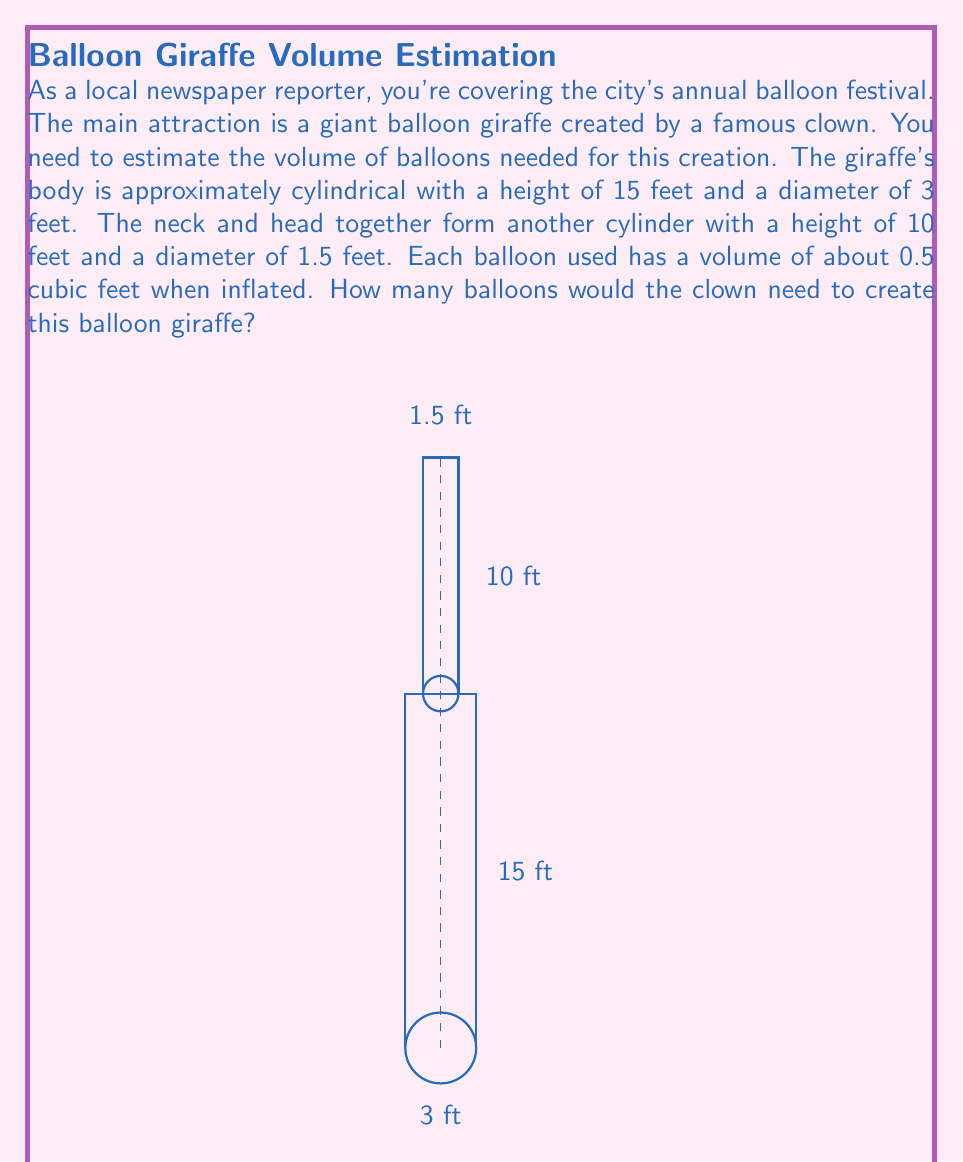Show me your answer to this math problem. Let's break this down step-by-step:

1) First, we need to calculate the volume of the giraffe's body:
   Volume of a cylinder = $\pi r^2 h$
   $r = 1.5$ feet (half the diameter)
   $h = 15$ feet
   $V_{body} = \pi (1.5)^2 (15) = 33.75\pi$ cubic feet

2) Next, calculate the volume of the neck and head:
   $r = 0.75$ feet (half the diameter)
   $h = 10$ feet
   $V_{neck} = \pi (0.75)^2 (10) = 5.625\pi$ cubic feet

3) Total volume of the balloon giraffe:
   $V_{total} = V_{body} + V_{neck} = 33.75\pi + 5.625\pi = 39.375\pi$ cubic feet

4) Convert $\pi$ to a decimal (rounded to 3 decimal places):
   $V_{total} = 39.375 * 3.142 = 123.716$ cubic feet

5) Each balloon has a volume of 0.5 cubic feet, so we divide the total volume by 0.5:
   Number of balloons = $\frac{123.716}{0.5} = 247.432$

6) Since we can't use a fraction of a balloon, we round up to the nearest whole number.
Answer: 248 balloons 